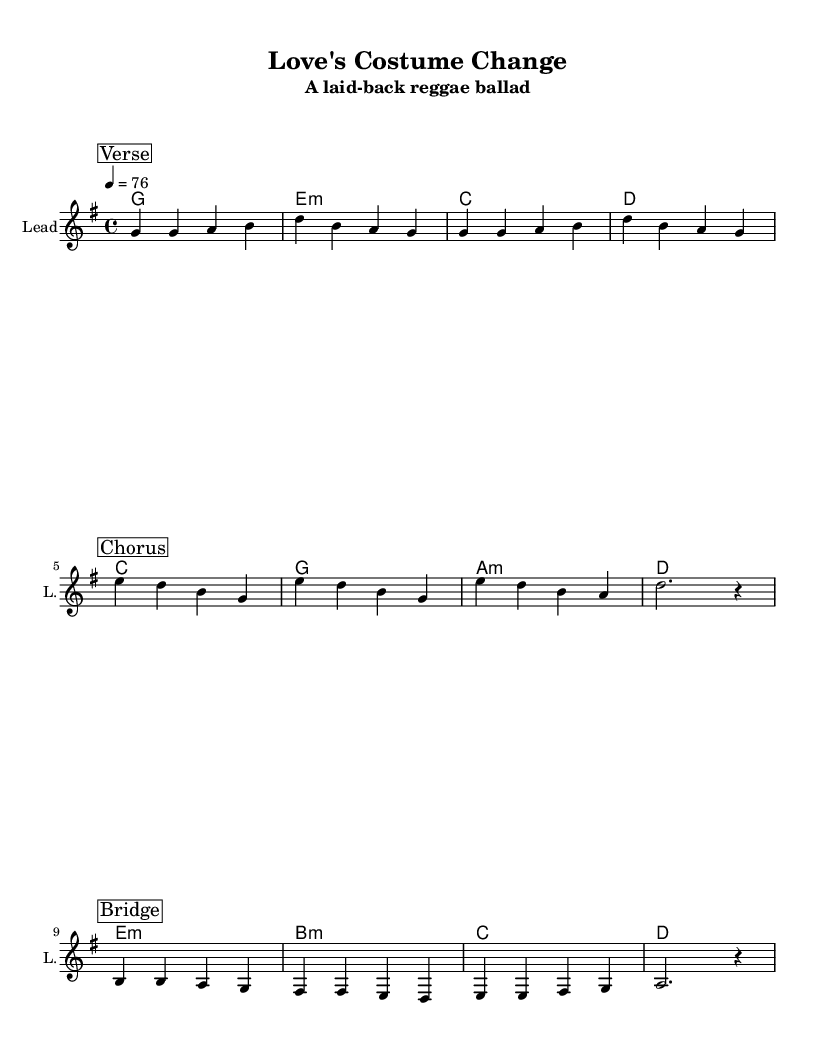What is the key signature of this music? The key signature shown in the global section is G major, which has one sharp (F#).
Answer: G major What is the time signature of this piece? The time signature indicated in the global section is 4/4, meaning there are four beats in each measure.
Answer: 4/4 What is the tempo marking in this sheet music? The tempo is marked as "4 = 76," indicating the quarter note is set to 76 beats per minute.
Answer: 76 Which section comes after the verse? By examining the order of the marked sections in the score, the chorus immediately follows the verse.
Answer: Chorus How many sections are there in total in this music? The sections outlined are Verse, Chorus, and Bridge, totaling three sections in the piece.
Answer: Three What type of chords are primarily used in this reggae ballad? The chord mode indicates a common progression often found in reggae, featuring major and minor chords.
Answer: Major and minor chords What is the typical rhythm pattern reflected in the verse? Analyzing the verse, it features a relaxed, syncopated rhythm characteristic of reggae, utilizing a steady beat with emphasis on off-beats.
Answer: Syncopated rhythm 